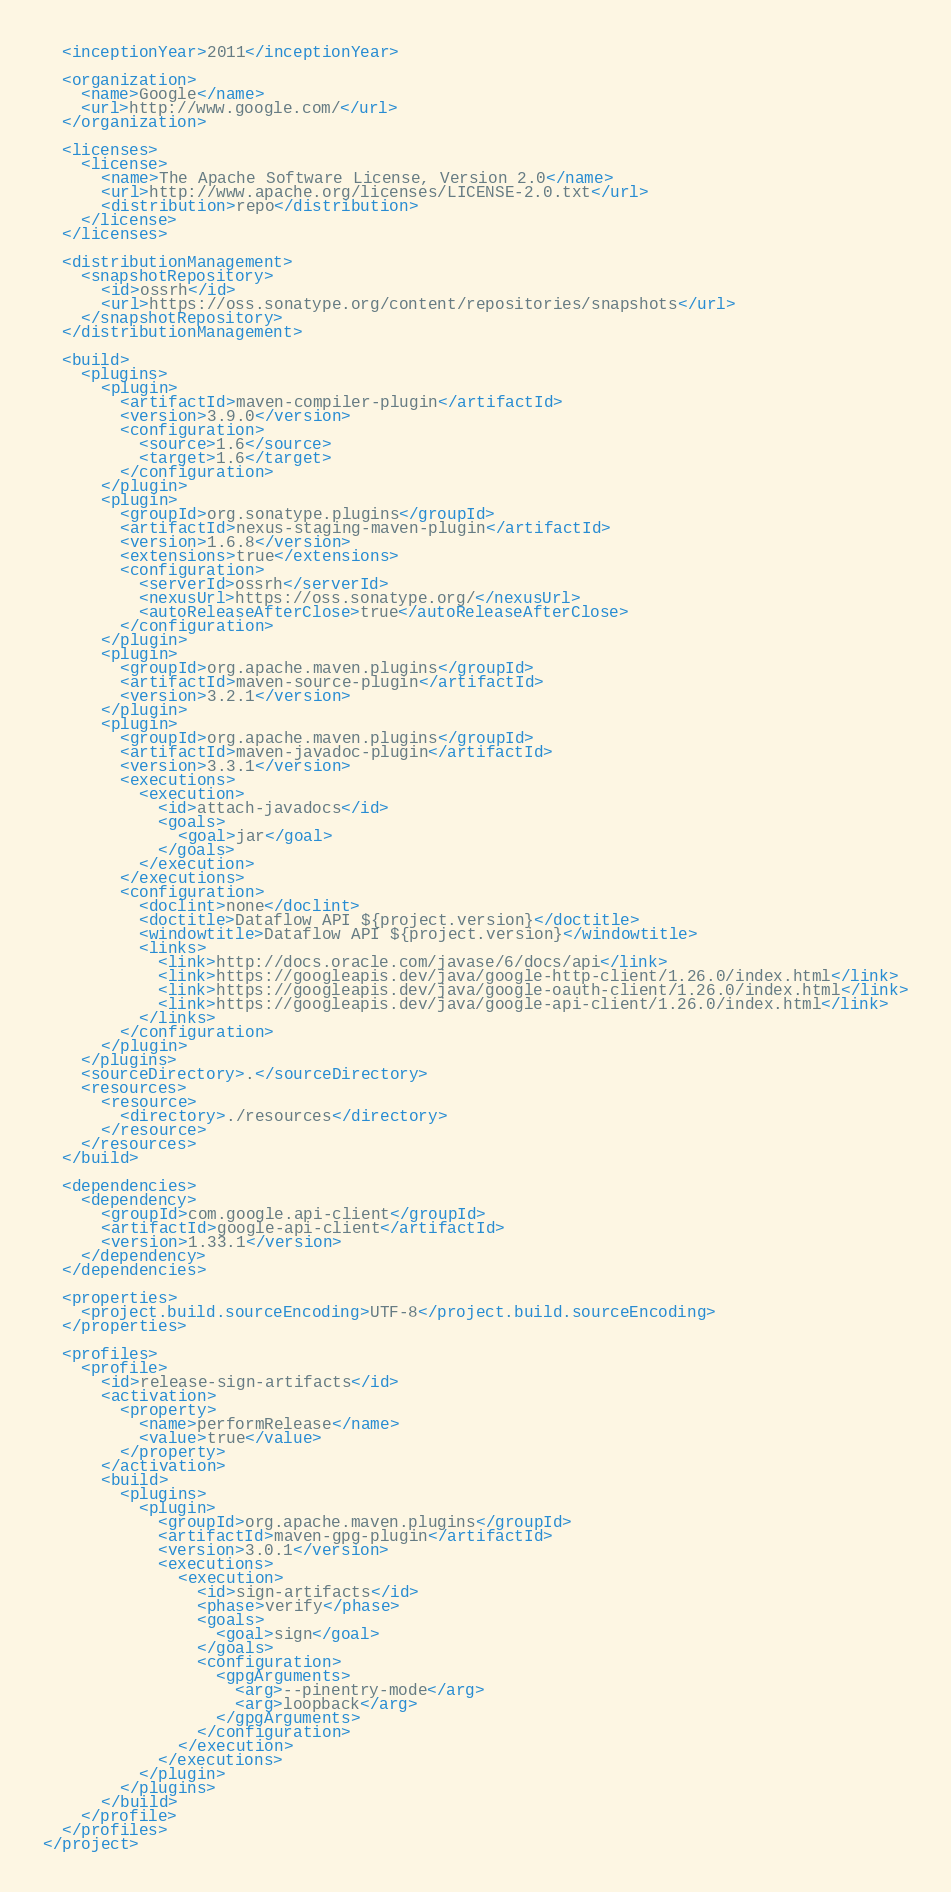Convert code to text. <code><loc_0><loc_0><loc_500><loc_500><_XML_>
  <inceptionYear>2011</inceptionYear>

  <organization>
    <name>Google</name>
    <url>http://www.google.com/</url>
  </organization>

  <licenses>
    <license>
      <name>The Apache Software License, Version 2.0</name>
      <url>http://www.apache.org/licenses/LICENSE-2.0.txt</url>
      <distribution>repo</distribution>
    </license>
  </licenses>

  <distributionManagement>
    <snapshotRepository>
      <id>ossrh</id>
      <url>https://oss.sonatype.org/content/repositories/snapshots</url>
    </snapshotRepository>
  </distributionManagement>

  <build>
    <plugins>
      <plugin>
        <artifactId>maven-compiler-plugin</artifactId>
        <version>3.9.0</version>
        <configuration>
          <source>1.6</source>
          <target>1.6</target>
        </configuration>
      </plugin>
      <plugin>
        <groupId>org.sonatype.plugins</groupId>
        <artifactId>nexus-staging-maven-plugin</artifactId>
        <version>1.6.8</version>
        <extensions>true</extensions>
        <configuration>
          <serverId>ossrh</serverId>
          <nexusUrl>https://oss.sonatype.org/</nexusUrl>
          <autoReleaseAfterClose>true</autoReleaseAfterClose>
        </configuration>
      </plugin>
      <plugin>
        <groupId>org.apache.maven.plugins</groupId>
        <artifactId>maven-source-plugin</artifactId>
        <version>3.2.1</version>
      </plugin>
      <plugin>
        <groupId>org.apache.maven.plugins</groupId>
        <artifactId>maven-javadoc-plugin</artifactId>
        <version>3.3.1</version>
        <executions>
          <execution>
            <id>attach-javadocs</id>
            <goals>
              <goal>jar</goal>
            </goals>
          </execution>
        </executions>
        <configuration>
          <doclint>none</doclint>
          <doctitle>Dataflow API ${project.version}</doctitle>
          <windowtitle>Dataflow API ${project.version}</windowtitle>
          <links>
            <link>http://docs.oracle.com/javase/6/docs/api</link>
            <link>https://googleapis.dev/java/google-http-client/1.26.0/index.html</link>
            <link>https://googleapis.dev/java/google-oauth-client/1.26.0/index.html</link>
            <link>https://googleapis.dev/java/google-api-client/1.26.0/index.html</link>
          </links>
        </configuration>
      </plugin>
    </plugins>
    <sourceDirectory>.</sourceDirectory>
    <resources>
      <resource>
        <directory>./resources</directory>
      </resource>
    </resources>
  </build>

  <dependencies>
    <dependency>
      <groupId>com.google.api-client</groupId>
      <artifactId>google-api-client</artifactId>
      <version>1.33.1</version>
    </dependency>
  </dependencies>

  <properties>
    <project.build.sourceEncoding>UTF-8</project.build.sourceEncoding>
  </properties>

  <profiles>
    <profile>
      <id>release-sign-artifacts</id>
      <activation>
        <property>
          <name>performRelease</name>
          <value>true</value>
        </property>
      </activation>
      <build>
        <plugins>
          <plugin>
            <groupId>org.apache.maven.plugins</groupId>
            <artifactId>maven-gpg-plugin</artifactId>
            <version>3.0.1</version>
            <executions>
              <execution>
                <id>sign-artifacts</id>
                <phase>verify</phase>
                <goals>
                  <goal>sign</goal>
                </goals>
                <configuration>
                  <gpgArguments>
                    <arg>--pinentry-mode</arg>
                    <arg>loopback</arg>
                  </gpgArguments>
                </configuration>
              </execution>
            </executions>
          </plugin>
        </plugins>
      </build>
    </profile>
  </profiles>
</project></code> 